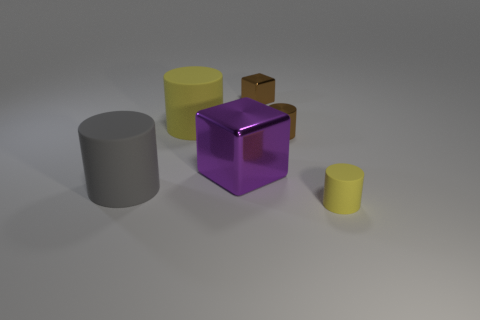Add 1 blue shiny cubes. How many objects exist? 7 Subtract all cubes. How many objects are left? 4 Subtract all tiny rubber things. Subtract all big gray rubber things. How many objects are left? 4 Add 6 big gray rubber cylinders. How many big gray rubber cylinders are left? 7 Add 2 small shiny spheres. How many small shiny spheres exist? 2 Subtract 0 blue cubes. How many objects are left? 6 